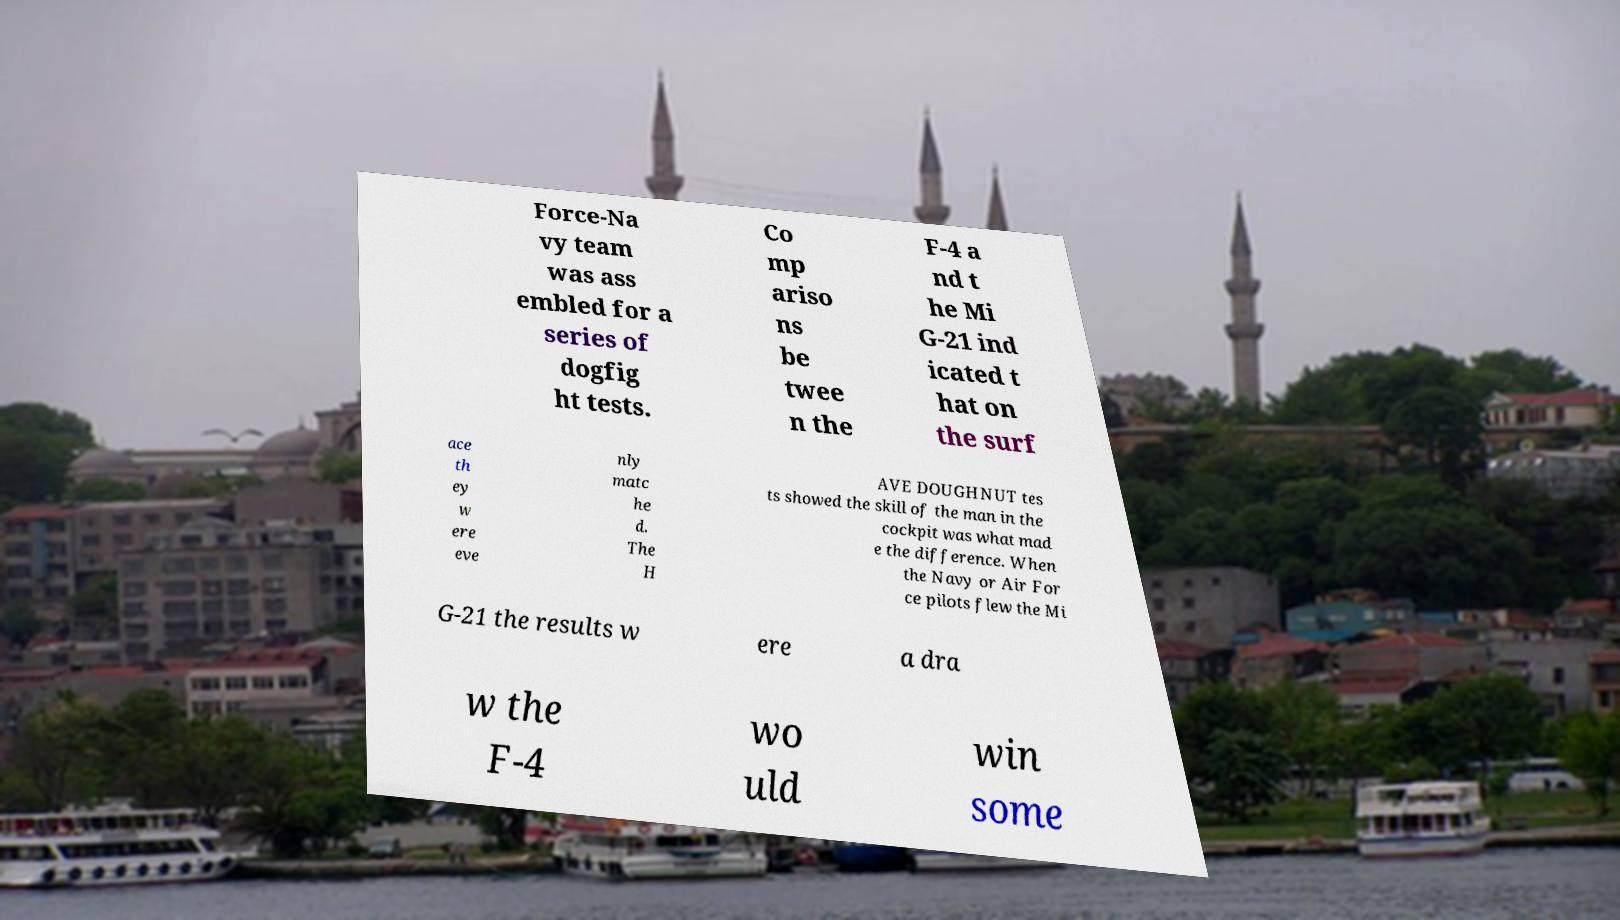For documentation purposes, I need the text within this image transcribed. Could you provide that? Force-Na vy team was ass embled for a series of dogfig ht tests. Co mp ariso ns be twee n the F-4 a nd t he Mi G-21 ind icated t hat on the surf ace th ey w ere eve nly matc he d. The H AVE DOUGHNUT tes ts showed the skill of the man in the cockpit was what mad e the difference. When the Navy or Air For ce pilots flew the Mi G-21 the results w ere a dra w the F-4 wo uld win some 